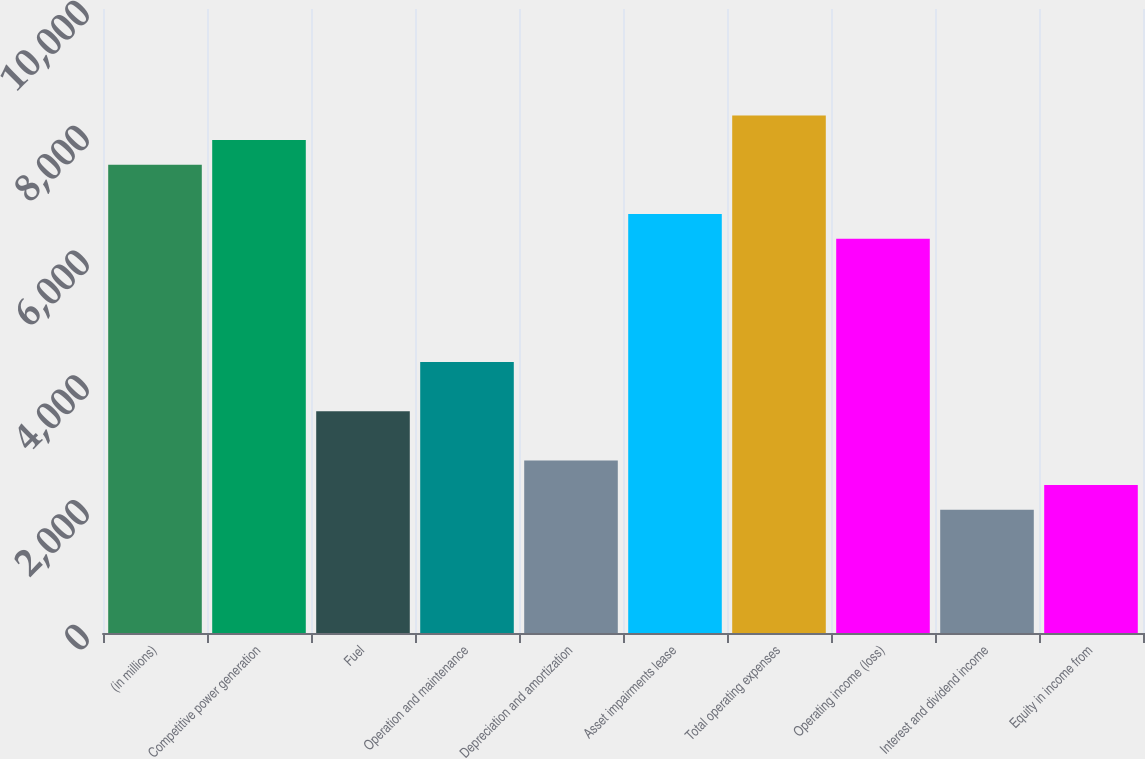Convert chart. <chart><loc_0><loc_0><loc_500><loc_500><bar_chart><fcel>(in millions)<fcel>Competitive power generation<fcel>Fuel<fcel>Operation and maintenance<fcel>Depreciation and amortization<fcel>Asset impairments lease<fcel>Total operating expenses<fcel>Operating income (loss)<fcel>Interest and dividend income<fcel>Equity in income from<nl><fcel>7504.1<fcel>7899<fcel>3555.1<fcel>4344.9<fcel>2765.3<fcel>6714.3<fcel>8293.9<fcel>6319.4<fcel>1975.5<fcel>2370.4<nl></chart> 